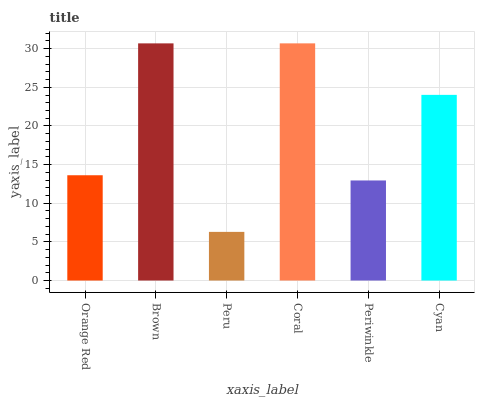Is Peru the minimum?
Answer yes or no. Yes. Is Coral the maximum?
Answer yes or no. Yes. Is Brown the minimum?
Answer yes or no. No. Is Brown the maximum?
Answer yes or no. No. Is Brown greater than Orange Red?
Answer yes or no. Yes. Is Orange Red less than Brown?
Answer yes or no. Yes. Is Orange Red greater than Brown?
Answer yes or no. No. Is Brown less than Orange Red?
Answer yes or no. No. Is Cyan the high median?
Answer yes or no. Yes. Is Orange Red the low median?
Answer yes or no. Yes. Is Periwinkle the high median?
Answer yes or no. No. Is Coral the low median?
Answer yes or no. No. 